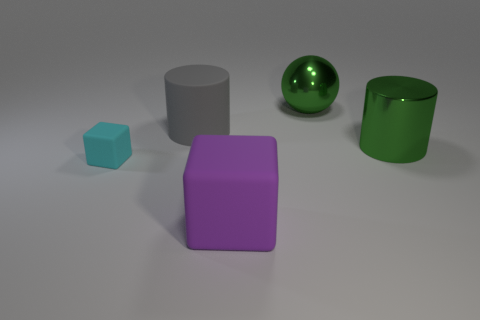Add 2 large purple matte things. How many objects exist? 7 Subtract all cubes. How many objects are left? 3 Add 1 small brown things. How many small brown things exist? 1 Subtract 0 yellow spheres. How many objects are left? 5 Subtract all large brown matte objects. Subtract all tiny cubes. How many objects are left? 4 Add 5 green things. How many green things are left? 7 